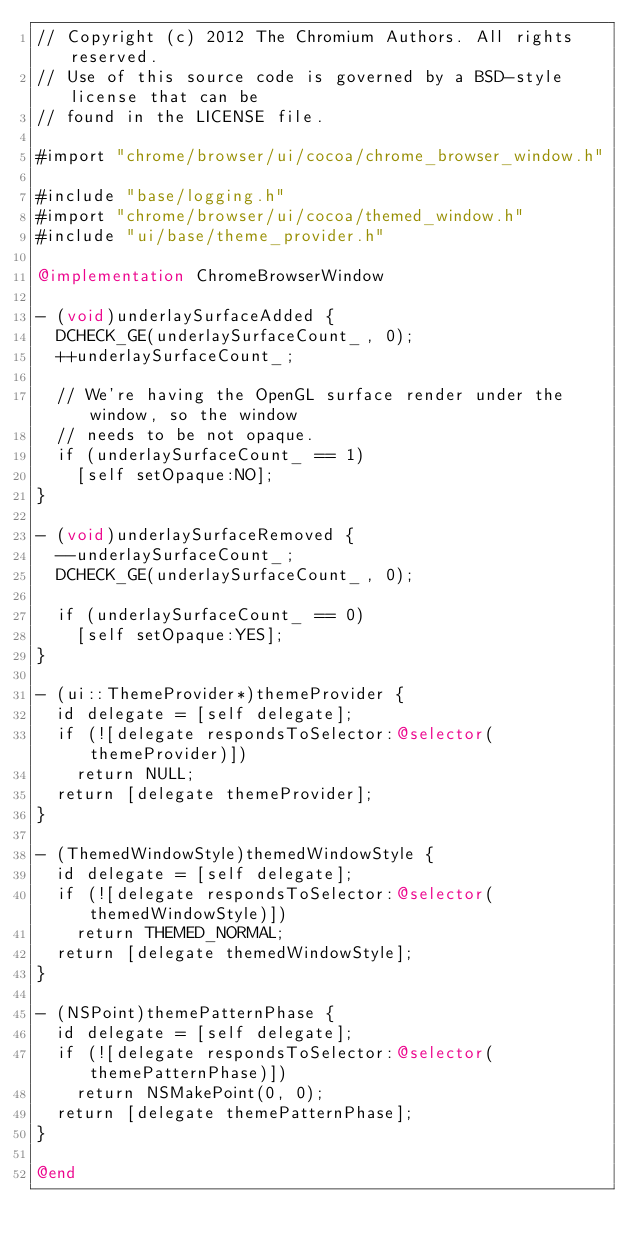<code> <loc_0><loc_0><loc_500><loc_500><_ObjectiveC_>// Copyright (c) 2012 The Chromium Authors. All rights reserved.
// Use of this source code is governed by a BSD-style license that can be
// found in the LICENSE file.

#import "chrome/browser/ui/cocoa/chrome_browser_window.h"

#include "base/logging.h"
#import "chrome/browser/ui/cocoa/themed_window.h"
#include "ui/base/theme_provider.h"

@implementation ChromeBrowserWindow

- (void)underlaySurfaceAdded {
  DCHECK_GE(underlaySurfaceCount_, 0);
  ++underlaySurfaceCount_;

  // We're having the OpenGL surface render under the window, so the window
  // needs to be not opaque.
  if (underlaySurfaceCount_ == 1)
    [self setOpaque:NO];
}

- (void)underlaySurfaceRemoved {
  --underlaySurfaceCount_;
  DCHECK_GE(underlaySurfaceCount_, 0);

  if (underlaySurfaceCount_ == 0)
    [self setOpaque:YES];
}

- (ui::ThemeProvider*)themeProvider {
  id delegate = [self delegate];
  if (![delegate respondsToSelector:@selector(themeProvider)])
    return NULL;
  return [delegate themeProvider];
}

- (ThemedWindowStyle)themedWindowStyle {
  id delegate = [self delegate];
  if (![delegate respondsToSelector:@selector(themedWindowStyle)])
    return THEMED_NORMAL;
  return [delegate themedWindowStyle];
}

- (NSPoint)themePatternPhase {
  id delegate = [self delegate];
  if (![delegate respondsToSelector:@selector(themePatternPhase)])
    return NSMakePoint(0, 0);
  return [delegate themePatternPhase];
}

@end
</code> 